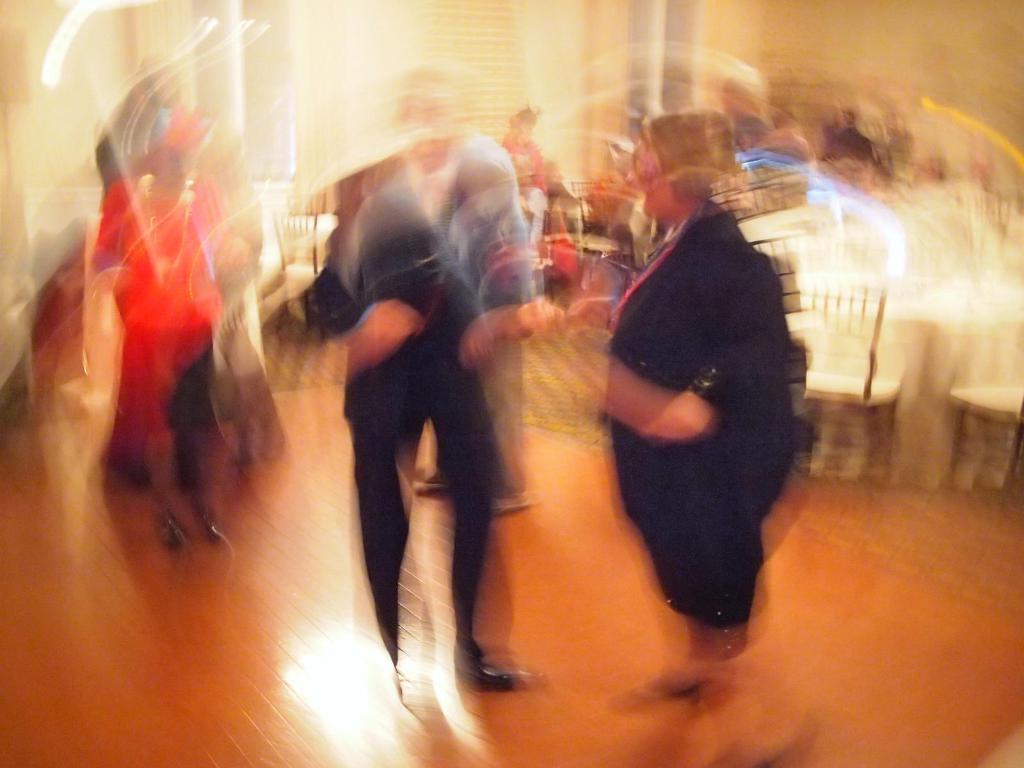Please provide a concise description of this image. In this image in front there are a few people standing on the floor. Behind them there are chairs. On the backside there is a wall. 